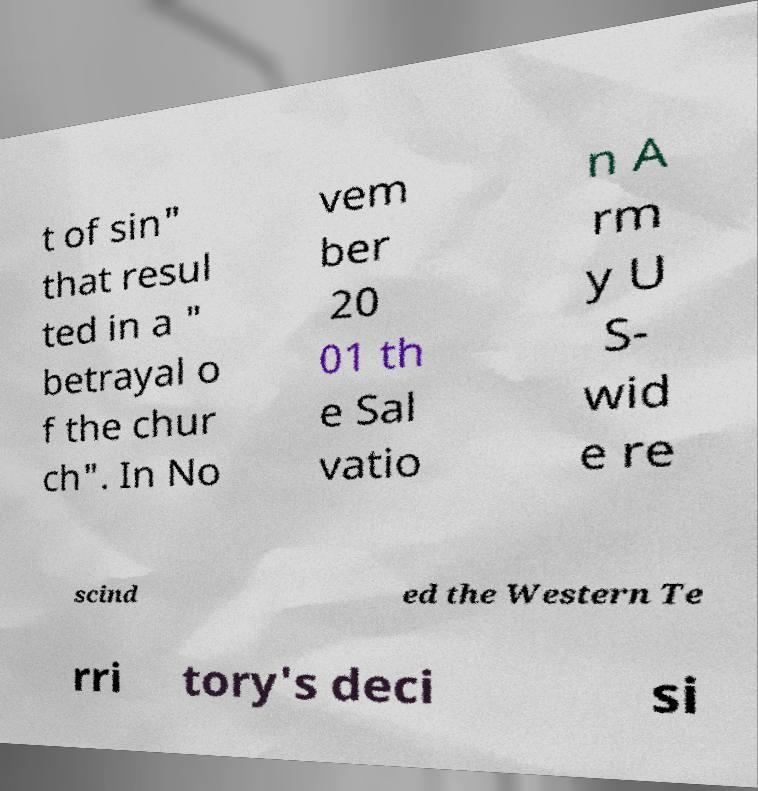Can you read and provide the text displayed in the image?This photo seems to have some interesting text. Can you extract and type it out for me? t of sin" that resul ted in a " betrayal o f the chur ch". In No vem ber 20 01 th e Sal vatio n A rm y U S- wid e re scind ed the Western Te rri tory's deci si 